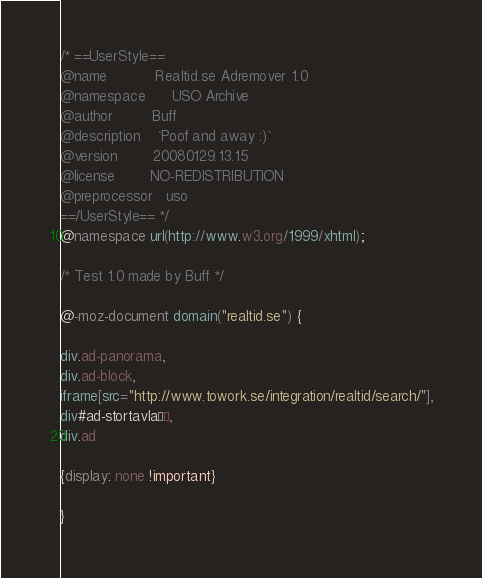<code> <loc_0><loc_0><loc_500><loc_500><_CSS_>/* ==UserStyle==
@name           Realtid.se Adremover 1.0
@namespace      USO Archive
@author         Buff
@description    `Poof and away :)`
@version        20080129.13.15
@license        NO-REDISTRIBUTION
@preprocessor   uso
==/UserStyle== */
@namespace url(http://www.w3.org/1999/xhtml);

/* Test 1.0 made by Buff */

@-moz-document domain("realtid.se") {

div.ad-panorama,
div.ad-block,
iframe[src="http://www.towork.se/integration/realtid/search/"],
div#ad-stortavlaÂ´,
div.ad

{display: none !important}

}</code> 